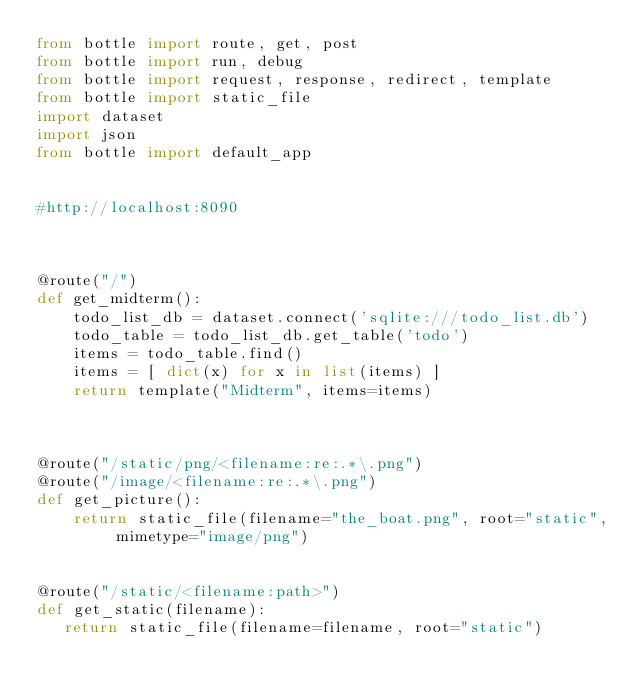Convert code to text. <code><loc_0><loc_0><loc_500><loc_500><_Python_>from bottle import route, get, post 
from bottle import run, debug
from bottle import request, response, redirect, template
from bottle import static_file
import dataset
import json
from bottle import default_app


#http://localhost:8090



@route("/")
def get_midterm():
    todo_list_db = dataset.connect('sqlite:///todo_list.db')
    todo_table = todo_list_db.get_table('todo')
    items = todo_table.find()
    items = [ dict(x) for x in list(items) ]
    return template("Midterm", items=items)



@route("/static/png/<filename:re:.*\.png")
@route("/image/<filename:re:.*\.png")
def get_picture():
    return static_file(filename="the_boat.png", root="static", mimetype="image/png")


@route("/static/<filename:path>")
def get_static(filename):
   return static_file(filename=filename, root="static")



</code> 